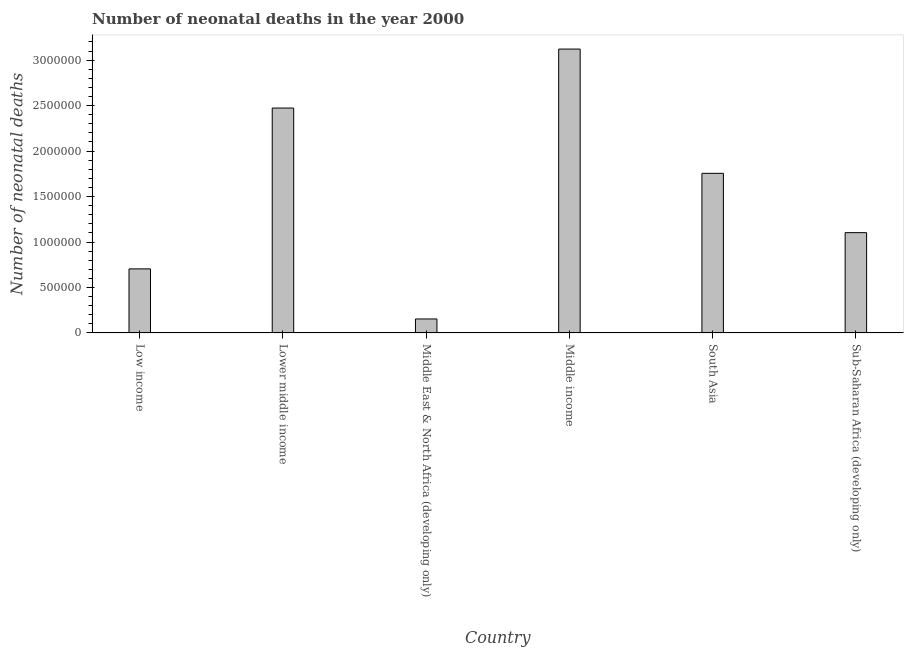Does the graph contain any zero values?
Provide a short and direct response. No. Does the graph contain grids?
Give a very brief answer. No. What is the title of the graph?
Ensure brevity in your answer.  Number of neonatal deaths in the year 2000. What is the label or title of the Y-axis?
Your response must be concise. Number of neonatal deaths. What is the number of neonatal deaths in South Asia?
Make the answer very short. 1.76e+06. Across all countries, what is the maximum number of neonatal deaths?
Your answer should be compact. 3.12e+06. Across all countries, what is the minimum number of neonatal deaths?
Keep it short and to the point. 1.54e+05. In which country was the number of neonatal deaths minimum?
Your answer should be very brief. Middle East & North Africa (developing only). What is the sum of the number of neonatal deaths?
Your answer should be compact. 9.31e+06. What is the difference between the number of neonatal deaths in Low income and Middle East & North Africa (developing only)?
Make the answer very short. 5.51e+05. What is the average number of neonatal deaths per country?
Provide a short and direct response. 1.55e+06. What is the median number of neonatal deaths?
Your answer should be compact. 1.43e+06. What is the ratio of the number of neonatal deaths in South Asia to that in Sub-Saharan Africa (developing only)?
Provide a short and direct response. 1.59. What is the difference between the highest and the second highest number of neonatal deaths?
Offer a terse response. 6.49e+05. Is the sum of the number of neonatal deaths in Middle income and Sub-Saharan Africa (developing only) greater than the maximum number of neonatal deaths across all countries?
Give a very brief answer. Yes. What is the difference between the highest and the lowest number of neonatal deaths?
Your answer should be compact. 2.97e+06. In how many countries, is the number of neonatal deaths greater than the average number of neonatal deaths taken over all countries?
Ensure brevity in your answer.  3. How many bars are there?
Give a very brief answer. 6. Are all the bars in the graph horizontal?
Make the answer very short. No. How many countries are there in the graph?
Offer a very short reply. 6. Are the values on the major ticks of Y-axis written in scientific E-notation?
Provide a short and direct response. No. What is the Number of neonatal deaths in Low income?
Your answer should be very brief. 7.04e+05. What is the Number of neonatal deaths in Lower middle income?
Keep it short and to the point. 2.47e+06. What is the Number of neonatal deaths in Middle East & North Africa (developing only)?
Your answer should be compact. 1.54e+05. What is the Number of neonatal deaths of Middle income?
Provide a short and direct response. 3.12e+06. What is the Number of neonatal deaths of South Asia?
Provide a succinct answer. 1.76e+06. What is the Number of neonatal deaths in Sub-Saharan Africa (developing only)?
Offer a terse response. 1.10e+06. What is the difference between the Number of neonatal deaths in Low income and Lower middle income?
Provide a succinct answer. -1.77e+06. What is the difference between the Number of neonatal deaths in Low income and Middle East & North Africa (developing only)?
Provide a succinct answer. 5.51e+05. What is the difference between the Number of neonatal deaths in Low income and Middle income?
Your response must be concise. -2.42e+06. What is the difference between the Number of neonatal deaths in Low income and South Asia?
Your response must be concise. -1.05e+06. What is the difference between the Number of neonatal deaths in Low income and Sub-Saharan Africa (developing only)?
Ensure brevity in your answer.  -3.99e+05. What is the difference between the Number of neonatal deaths in Lower middle income and Middle East & North Africa (developing only)?
Provide a succinct answer. 2.32e+06. What is the difference between the Number of neonatal deaths in Lower middle income and Middle income?
Your answer should be compact. -6.49e+05. What is the difference between the Number of neonatal deaths in Lower middle income and South Asia?
Ensure brevity in your answer.  7.18e+05. What is the difference between the Number of neonatal deaths in Lower middle income and Sub-Saharan Africa (developing only)?
Your answer should be compact. 1.37e+06. What is the difference between the Number of neonatal deaths in Middle East & North Africa (developing only) and Middle income?
Give a very brief answer. -2.97e+06. What is the difference between the Number of neonatal deaths in Middle East & North Africa (developing only) and South Asia?
Give a very brief answer. -1.60e+06. What is the difference between the Number of neonatal deaths in Middle East & North Africa (developing only) and Sub-Saharan Africa (developing only)?
Make the answer very short. -9.49e+05. What is the difference between the Number of neonatal deaths in Middle income and South Asia?
Offer a very short reply. 1.37e+06. What is the difference between the Number of neonatal deaths in Middle income and Sub-Saharan Africa (developing only)?
Provide a succinct answer. 2.02e+06. What is the difference between the Number of neonatal deaths in South Asia and Sub-Saharan Africa (developing only)?
Make the answer very short. 6.52e+05. What is the ratio of the Number of neonatal deaths in Low income to that in Lower middle income?
Your answer should be compact. 0.28. What is the ratio of the Number of neonatal deaths in Low income to that in Middle East & North Africa (developing only)?
Give a very brief answer. 4.58. What is the ratio of the Number of neonatal deaths in Low income to that in Middle income?
Your response must be concise. 0.23. What is the ratio of the Number of neonatal deaths in Low income to that in South Asia?
Offer a terse response. 0.4. What is the ratio of the Number of neonatal deaths in Low income to that in Sub-Saharan Africa (developing only)?
Ensure brevity in your answer.  0.64. What is the ratio of the Number of neonatal deaths in Lower middle income to that in Middle East & North Africa (developing only)?
Offer a very short reply. 16.09. What is the ratio of the Number of neonatal deaths in Lower middle income to that in Middle income?
Ensure brevity in your answer.  0.79. What is the ratio of the Number of neonatal deaths in Lower middle income to that in South Asia?
Give a very brief answer. 1.41. What is the ratio of the Number of neonatal deaths in Lower middle income to that in Sub-Saharan Africa (developing only)?
Keep it short and to the point. 2.24. What is the ratio of the Number of neonatal deaths in Middle East & North Africa (developing only) to that in Middle income?
Keep it short and to the point. 0.05. What is the ratio of the Number of neonatal deaths in Middle East & North Africa (developing only) to that in South Asia?
Keep it short and to the point. 0.09. What is the ratio of the Number of neonatal deaths in Middle East & North Africa (developing only) to that in Sub-Saharan Africa (developing only)?
Offer a very short reply. 0.14. What is the ratio of the Number of neonatal deaths in Middle income to that in South Asia?
Make the answer very short. 1.78. What is the ratio of the Number of neonatal deaths in Middle income to that in Sub-Saharan Africa (developing only)?
Your answer should be compact. 2.83. What is the ratio of the Number of neonatal deaths in South Asia to that in Sub-Saharan Africa (developing only)?
Your response must be concise. 1.59. 